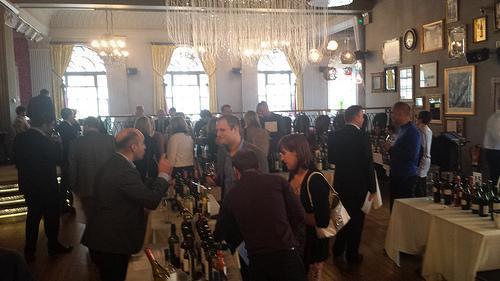How many windows are in photo?
Give a very brief answer. 4. 